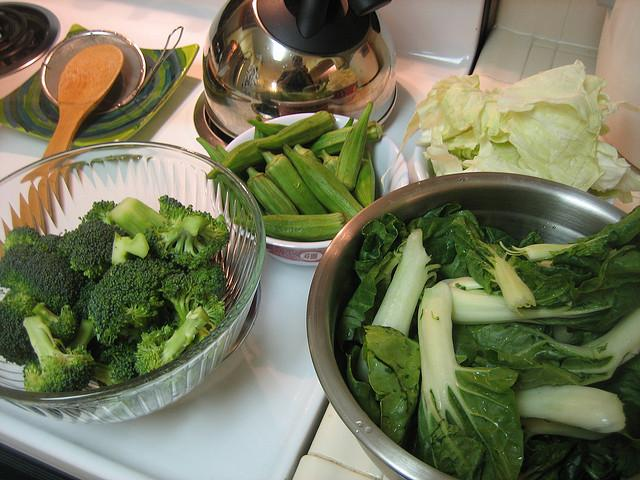What do all the foods being prepared have in common? Please explain your reasoning. vegetables. A table has several bowls filled with green leafy food items. vegetables are often green and leafy. 